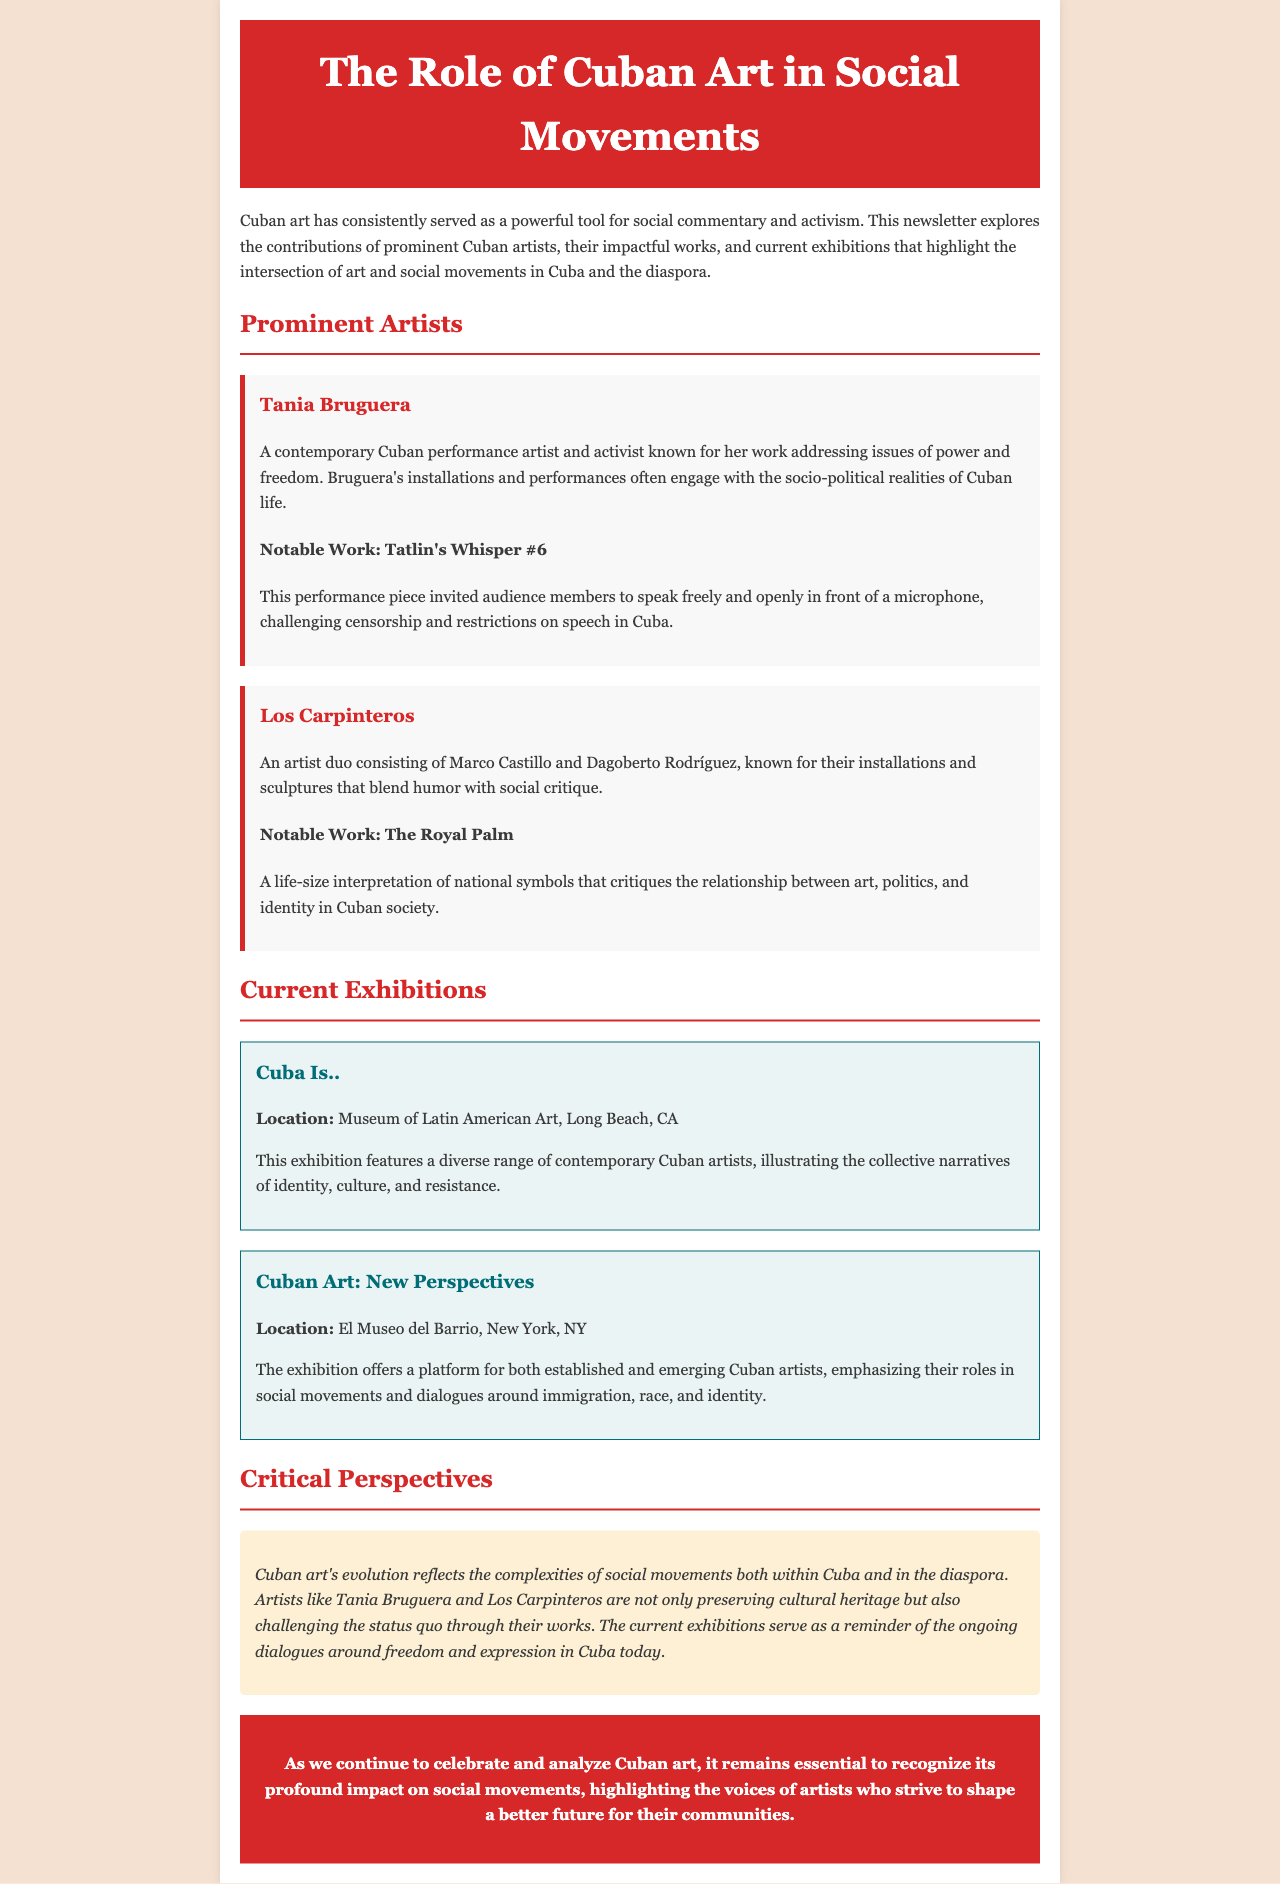What is the title of the newsletter? The title of the newsletter is provided in the header section of the document.
Answer: The Role of Cuban Art in Social Movements Who is a prominent contemporary Cuban artist discussed in the newsletter? The newsletter highlights several prominent artists; one of them is named specifically in the section on artists.
Answer: Tania Bruguera What is the notable work of Los Carpinteros mentioned in the newsletter? The newsletter specifically identifies a notable work by this artist duo in their section.
Answer: The Royal Palm Where is the exhibition "Cuba Is.." located? The location of the exhibition is mentioned in the section dedicated to current exhibitions.
Answer: Museum of Latin American Art, Long Beach, CA What theme do the current exhibitions in the newsletter address? The current exhibitions are mentioned to focus on specific themes related to artists and social movements in Cuba.
Answer: Identity, culture, and resistance How does Cuban art reflect social movements according to the critical perspectives section? The critical perspectives section discusses the relationship between art and social movements in Cuba.
Answer: Complexity and dialogue What color is used for the header background? The newsletter uses a specific color code for the header background, highlighted in the style section.
Answer: #d62828 What is the main goal stated in the conclusion of the newsletter? The conclusion summarizes the primary aim related to the celebration and analysis of Cuban art.
Answer: Recognize its profound impact on social movements 